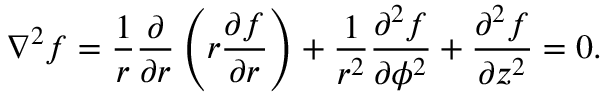<formula> <loc_0><loc_0><loc_500><loc_500>\nabla ^ { 2 } f = { \frac { 1 } { r } } { \frac { \partial } { \partial r } } \left ( r { \frac { \partial f } { \partial r } } \right ) + { \frac { 1 } { r ^ { 2 } } } { \frac { \partial ^ { 2 } f } { \partial \phi ^ { 2 } } } + { \frac { \partial ^ { 2 } f } { \partial z ^ { 2 } } } = 0 .</formula> 